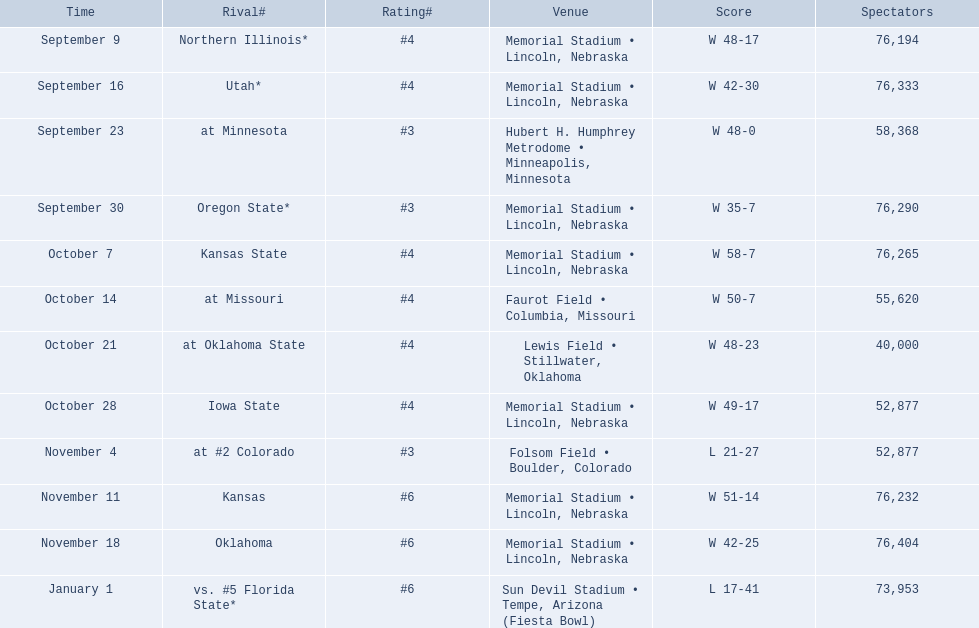When did nebraska play oregon state? September 30. What was the attendance at the september 30 game? 76,290. 